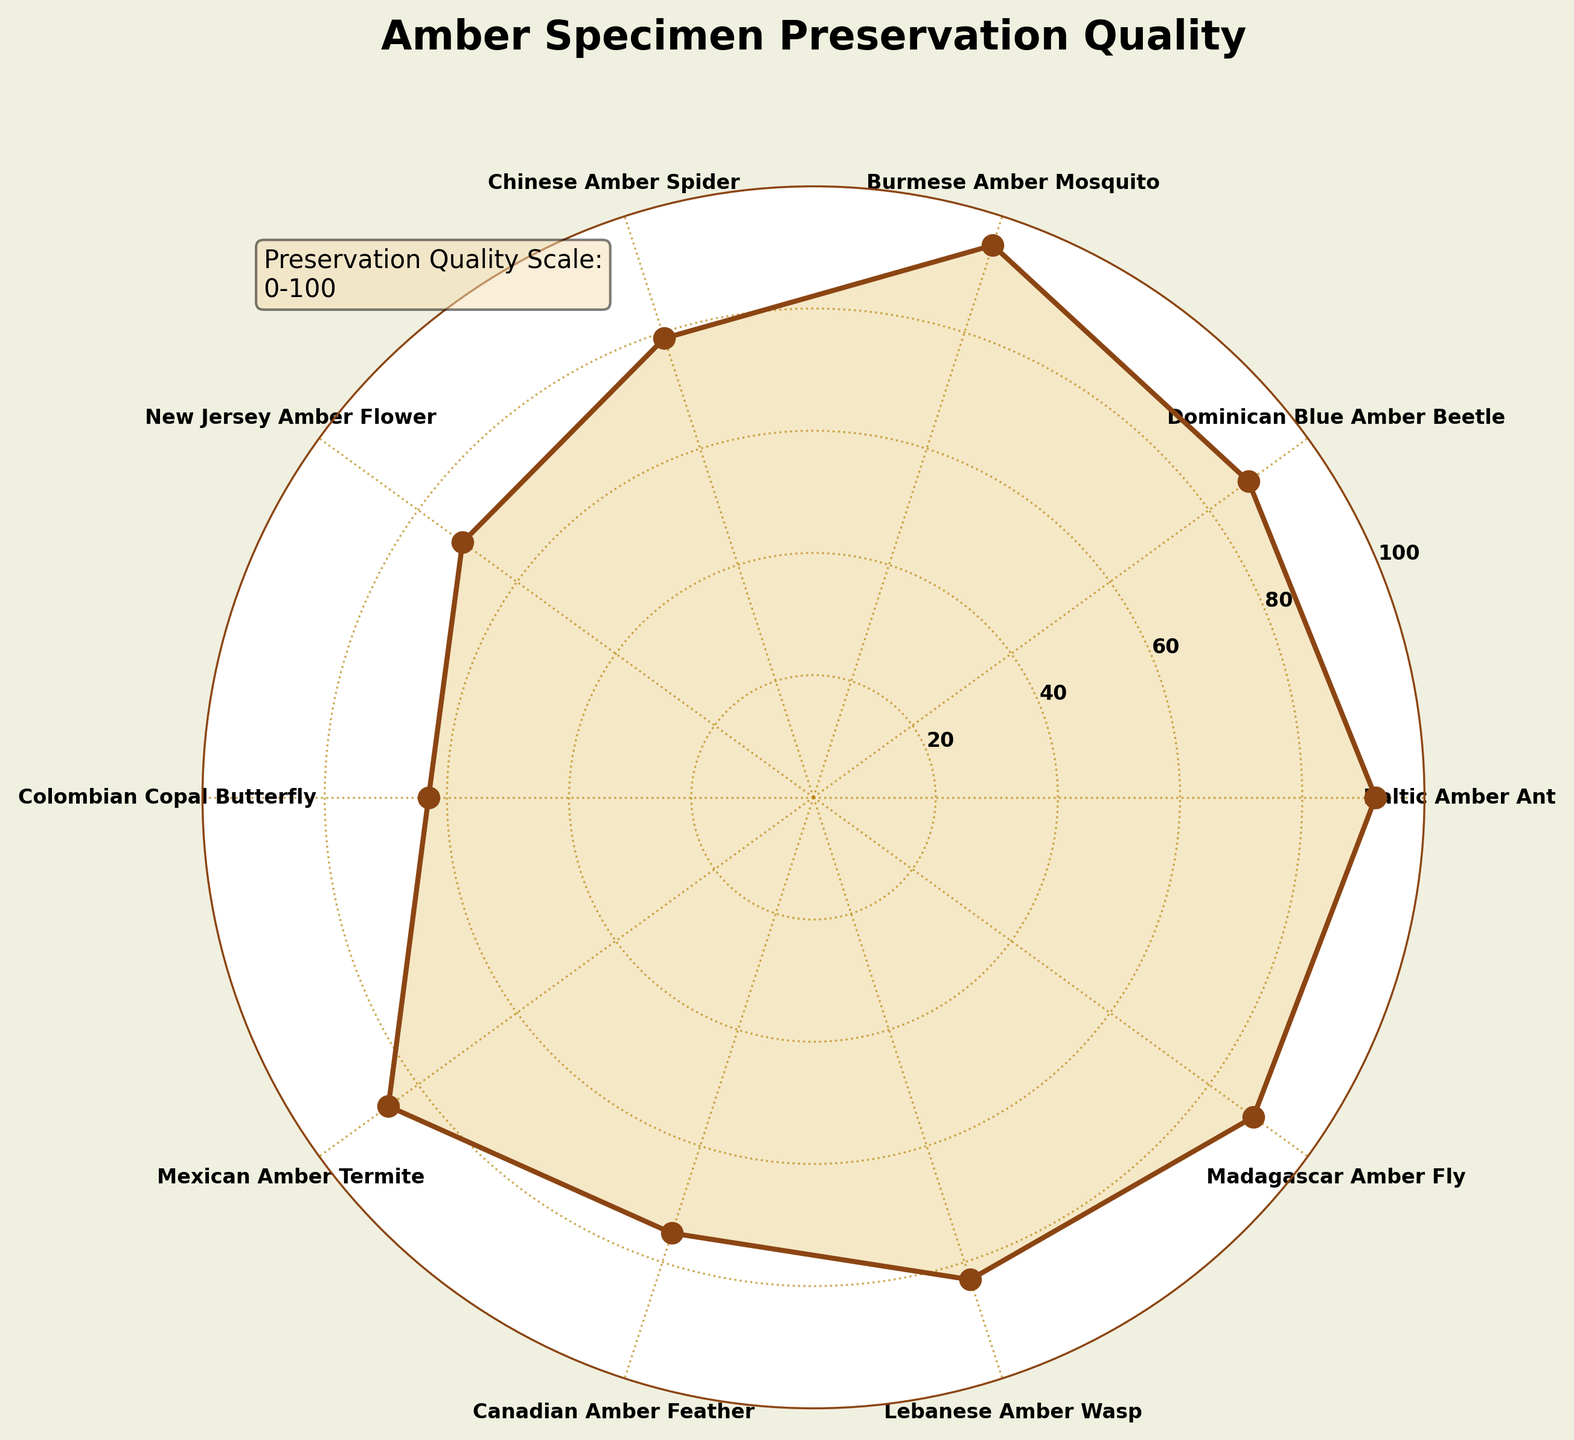How many different amber specimens are shown in the plot? The plot displays each specimen's preservation quality as data points on the polar chart. By counting the labels around the plot, we find there are 10 different amber specimens.
Answer: 10 Which amber specimen has the highest preservation quality? By examining the radial values on the plot, the highest value is at 95, which corresponds to the Burmese Amber Mosquito.
Answer: Burmese Amber Mosquito What is the average preservation quality of all the amber specimens? Sum all the preservation quality values shown in the plot (92 + 88 + 95 + 79 + 71 + 63 + 86 + 75 + 83 + 89) = 821. Divide by the number of specimens (10). The average is 821 / 10 = 82.1
Answer: 82.1 Which specimen has the lowest preservation quality and what is its value? Looking at the plot, the lowest radial value is 63, which corresponds to the Colombian Copal Butterfly.
Answer: Colombian Copal Butterfly with 63 Is the preservation quality of Mexican Amber Termite greater than that of the Lebanese Amber Wasp? The radial value for Mexican Amber Termite is 86 and for Lebanese Amber Wasp is 83, confirmed by checking the respective positions on the plot.
Answer: Yes What is the difference between the highest and lowest preservation qualities? The highest value is 95 (Burmese Amber Mosquito) and the lowest value is 63 (Colombian Copal Butterfly). The difference is 95 - 63 = 32.
Answer: 32 What preservation quality range do most specimens fall into (using intervals of 20)? Observing the radial labels, most values fall between 60 and 100, with many between 80 and 100, determined by the specimen data points' clustering in those radial intervals.
Answer: 80-100 Which two specimens have the closest preservation quality, and what are their values? Comparing the values, the closest pair is the Dominican Blue Amber Beetle (88) and Madagascar Amber Fly (89), with a difference of 1.
Answer: Dominican Blue Amber Beetle (88) and Madagascar Amber Fly (89) Are there any specimens with a preservation quality below 70? If so, list them. Checking radial values below the 70 mark on the plot, only the Colombian Copal Butterfly has a preservation quality below 70, specifically at 63.
Answer: Colombian Copal Butterfly 